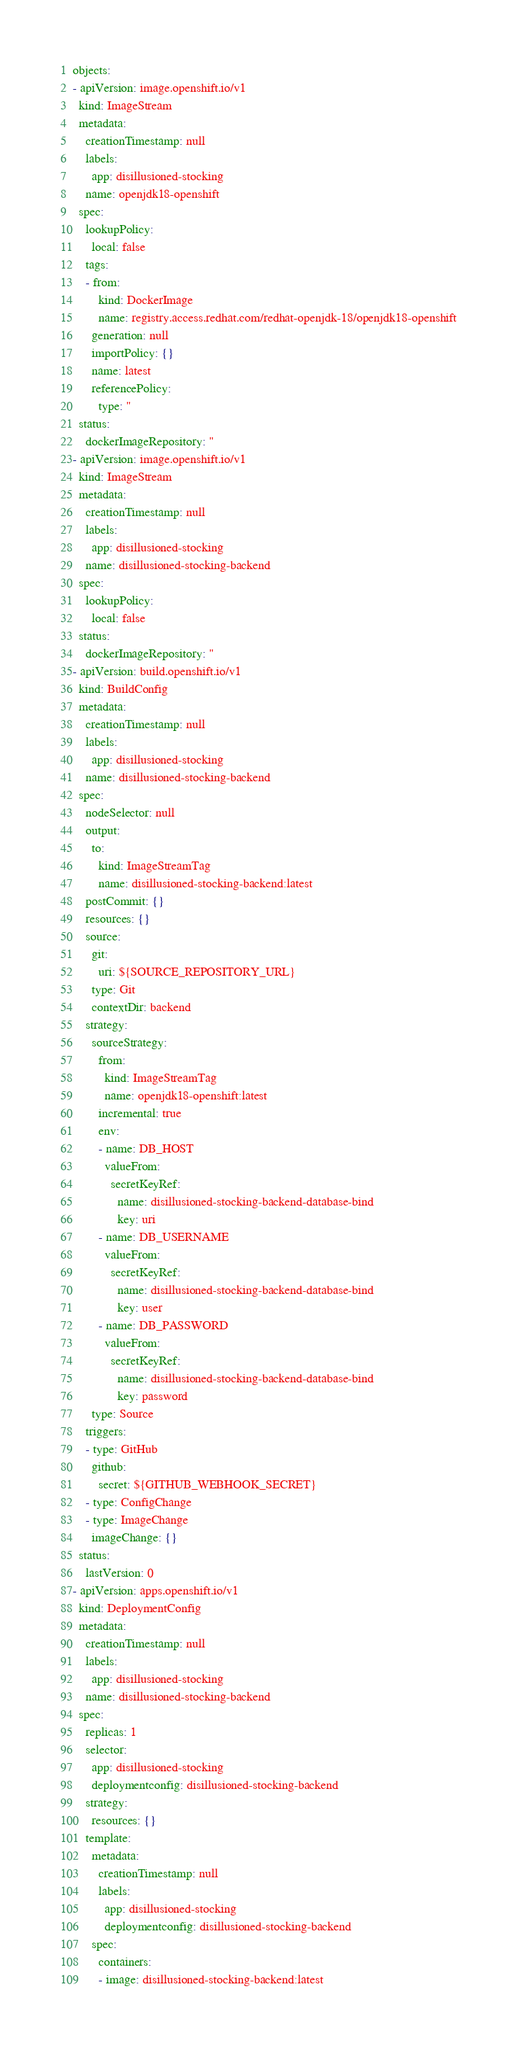<code> <loc_0><loc_0><loc_500><loc_500><_YAML_>objects:
- apiVersion: image.openshift.io/v1
  kind: ImageStream
  metadata:
    creationTimestamp: null
    labels:
      app: disillusioned-stocking
    name: openjdk18-openshift
  spec:
    lookupPolicy:
      local: false
    tags:
    - from:
        kind: DockerImage
        name: registry.access.redhat.com/redhat-openjdk-18/openjdk18-openshift
      generation: null
      importPolicy: {}
      name: latest
      referencePolicy:
        type: ''
  status:
    dockerImageRepository: ''
- apiVersion: image.openshift.io/v1
  kind: ImageStream
  metadata:
    creationTimestamp: null
    labels:
      app: disillusioned-stocking
    name: disillusioned-stocking-backend
  spec:
    lookupPolicy:
      local: false
  status:
    dockerImageRepository: ''
- apiVersion: build.openshift.io/v1
  kind: BuildConfig
  metadata:
    creationTimestamp: null
    labels:
      app: disillusioned-stocking
    name: disillusioned-stocking-backend
  spec:
    nodeSelector: null
    output:
      to:
        kind: ImageStreamTag
        name: disillusioned-stocking-backend:latest
    postCommit: {}
    resources: {}
    source:
      git:
        uri: ${SOURCE_REPOSITORY_URL}
      type: Git
      contextDir: backend
    strategy:
      sourceStrategy:
        from:
          kind: ImageStreamTag
          name: openjdk18-openshift:latest
        incremental: true
        env:
        - name: DB_HOST
          valueFrom:
            secretKeyRef:
              name: disillusioned-stocking-backend-database-bind
              key: uri
        - name: DB_USERNAME
          valueFrom:
            secretKeyRef:
              name: disillusioned-stocking-backend-database-bind
              key: user
        - name: DB_PASSWORD
          valueFrom:
            secretKeyRef:
              name: disillusioned-stocking-backend-database-bind
              key: password
      type: Source
    triggers:
    - type: GitHub
      github:
        secret: ${GITHUB_WEBHOOK_SECRET}
    - type: ConfigChange
    - type: ImageChange
      imageChange: {}
  status:
    lastVersion: 0
- apiVersion: apps.openshift.io/v1
  kind: DeploymentConfig
  metadata:
    creationTimestamp: null
    labels:
      app: disillusioned-stocking
    name: disillusioned-stocking-backend
  spec:
    replicas: 1
    selector:
      app: disillusioned-stocking
      deploymentconfig: disillusioned-stocking-backend
    strategy:
      resources: {}
    template:
      metadata:
        creationTimestamp: null
        labels:
          app: disillusioned-stocking
          deploymentconfig: disillusioned-stocking-backend
      spec:
        containers:
        - image: disillusioned-stocking-backend:latest</code> 